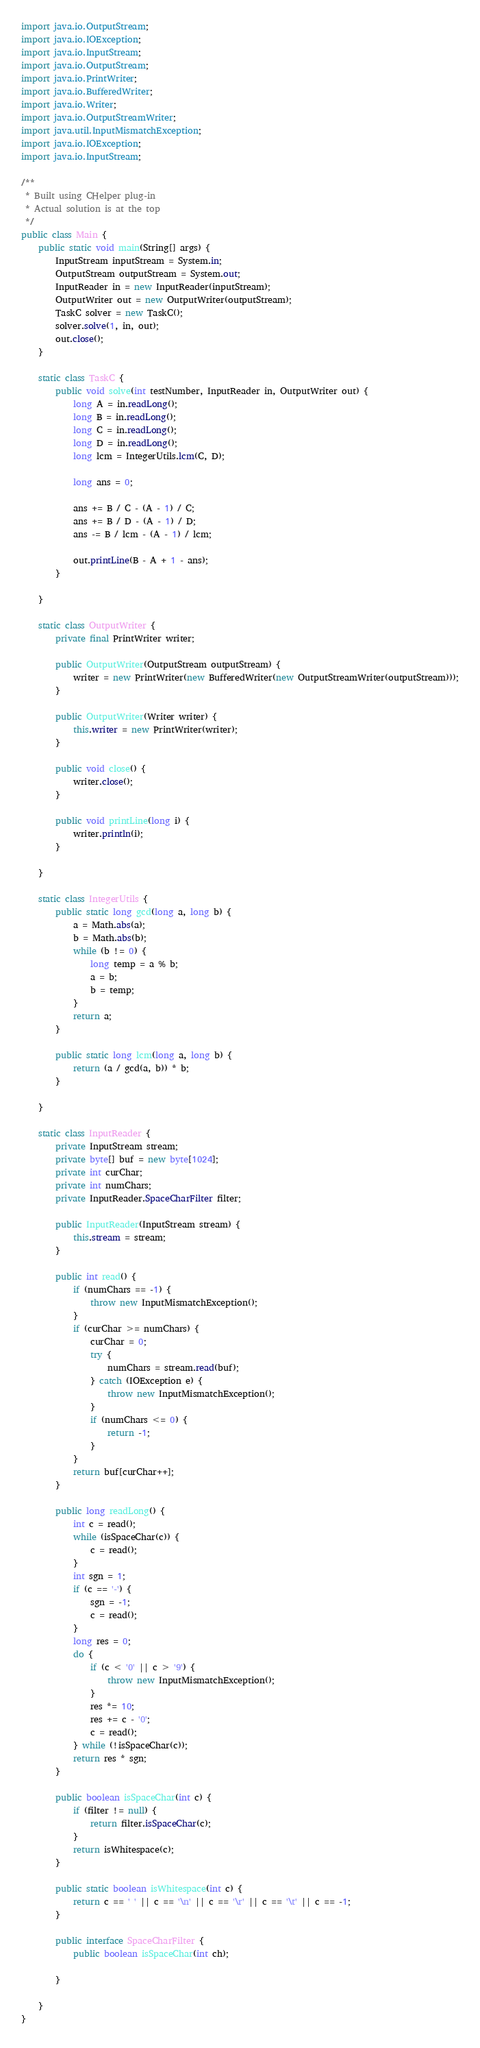<code> <loc_0><loc_0><loc_500><loc_500><_Java_>import java.io.OutputStream;
import java.io.IOException;
import java.io.InputStream;
import java.io.OutputStream;
import java.io.PrintWriter;
import java.io.BufferedWriter;
import java.io.Writer;
import java.io.OutputStreamWriter;
import java.util.InputMismatchException;
import java.io.IOException;
import java.io.InputStream;

/**
 * Built using CHelper plug-in
 * Actual solution is at the top
 */
public class Main {
    public static void main(String[] args) {
        InputStream inputStream = System.in;
        OutputStream outputStream = System.out;
        InputReader in = new InputReader(inputStream);
        OutputWriter out = new OutputWriter(outputStream);
        TaskC solver = new TaskC();
        solver.solve(1, in, out);
        out.close();
    }

    static class TaskC {
        public void solve(int testNumber, InputReader in, OutputWriter out) {
            long A = in.readLong();
            long B = in.readLong();
            long C = in.readLong();
            long D = in.readLong();
            long lcm = IntegerUtils.lcm(C, D);

            long ans = 0;

            ans += B / C - (A - 1) / C;
            ans += B / D - (A - 1) / D;
            ans -= B / lcm - (A - 1) / lcm;

            out.printLine(B - A + 1 - ans);
        }

    }

    static class OutputWriter {
        private final PrintWriter writer;

        public OutputWriter(OutputStream outputStream) {
            writer = new PrintWriter(new BufferedWriter(new OutputStreamWriter(outputStream)));
        }

        public OutputWriter(Writer writer) {
            this.writer = new PrintWriter(writer);
        }

        public void close() {
            writer.close();
        }

        public void printLine(long i) {
            writer.println(i);
        }

    }

    static class IntegerUtils {
        public static long gcd(long a, long b) {
            a = Math.abs(a);
            b = Math.abs(b);
            while (b != 0) {
                long temp = a % b;
                a = b;
                b = temp;
            }
            return a;
        }

        public static long lcm(long a, long b) {
            return (a / gcd(a, b)) * b;
        }

    }

    static class InputReader {
        private InputStream stream;
        private byte[] buf = new byte[1024];
        private int curChar;
        private int numChars;
        private InputReader.SpaceCharFilter filter;

        public InputReader(InputStream stream) {
            this.stream = stream;
        }

        public int read() {
            if (numChars == -1) {
                throw new InputMismatchException();
            }
            if (curChar >= numChars) {
                curChar = 0;
                try {
                    numChars = stream.read(buf);
                } catch (IOException e) {
                    throw new InputMismatchException();
                }
                if (numChars <= 0) {
                    return -1;
                }
            }
            return buf[curChar++];
        }

        public long readLong() {
            int c = read();
            while (isSpaceChar(c)) {
                c = read();
            }
            int sgn = 1;
            if (c == '-') {
                sgn = -1;
                c = read();
            }
            long res = 0;
            do {
                if (c < '0' || c > '9') {
                    throw new InputMismatchException();
                }
                res *= 10;
                res += c - '0';
                c = read();
            } while (!isSpaceChar(c));
            return res * sgn;
        }

        public boolean isSpaceChar(int c) {
            if (filter != null) {
                return filter.isSpaceChar(c);
            }
            return isWhitespace(c);
        }

        public static boolean isWhitespace(int c) {
            return c == ' ' || c == '\n' || c == '\r' || c == '\t' || c == -1;
        }

        public interface SpaceCharFilter {
            public boolean isSpaceChar(int ch);

        }

    }
}

</code> 